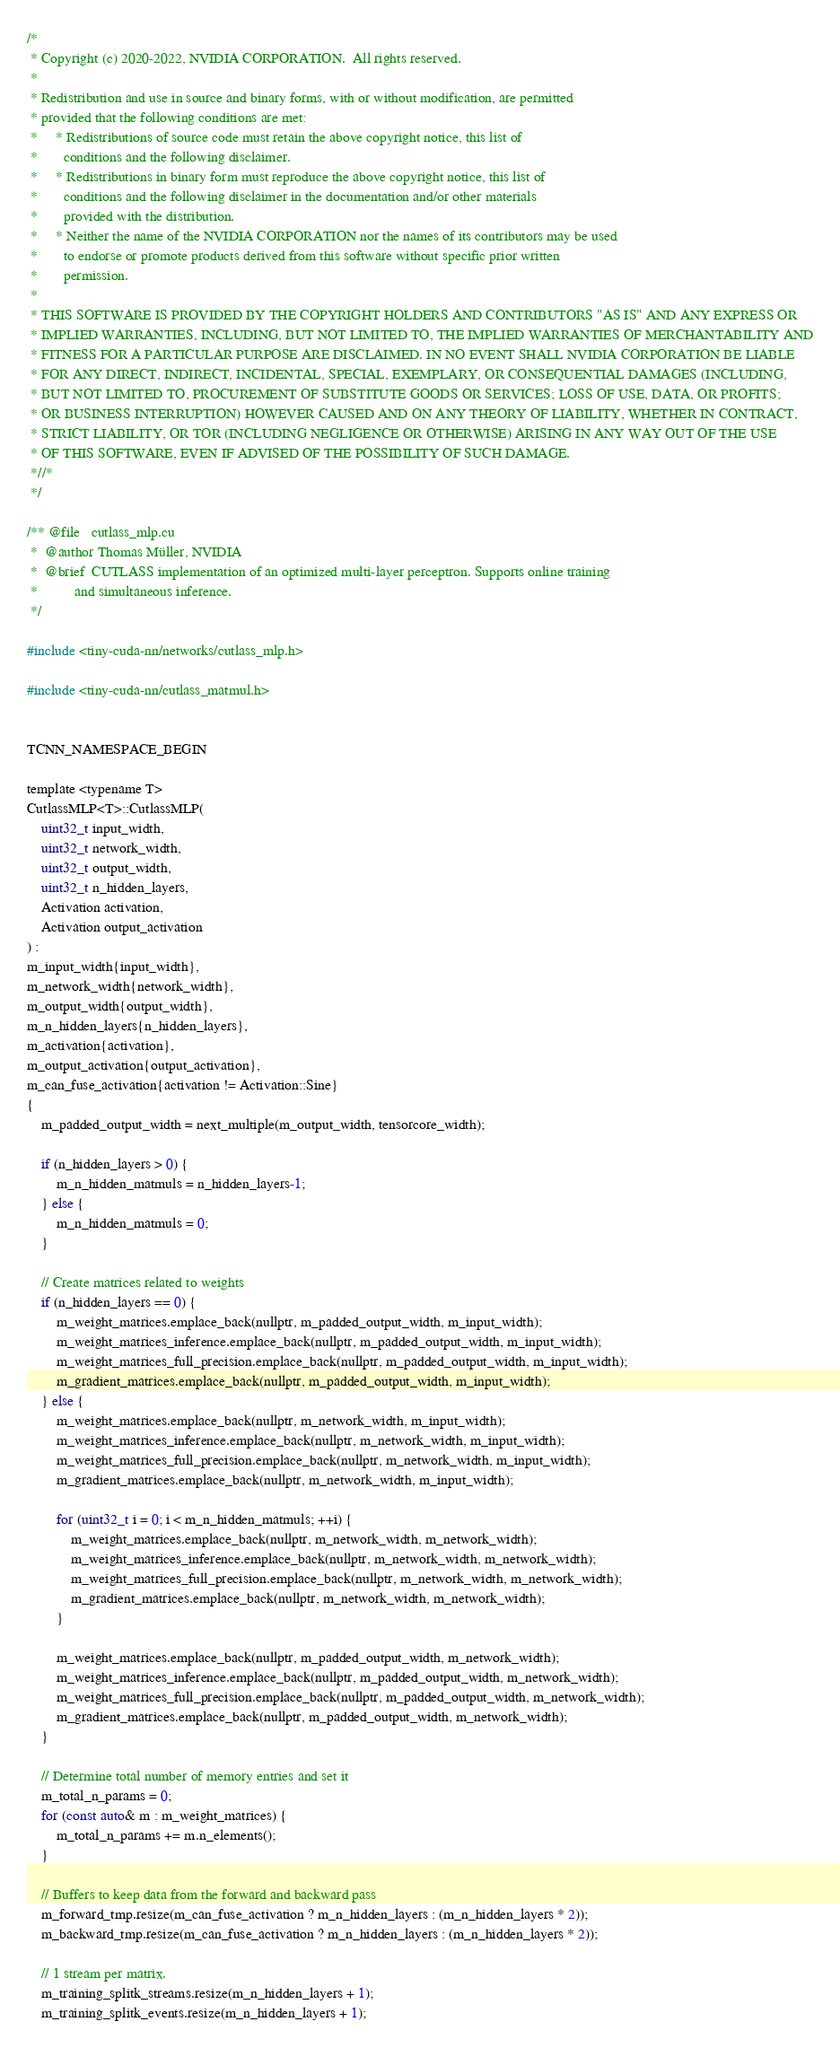Convert code to text. <code><loc_0><loc_0><loc_500><loc_500><_Cuda_>/*
 * Copyright (c) 2020-2022, NVIDIA CORPORATION.  All rights reserved.
 * 
 * Redistribution and use in source and binary forms, with or without modification, are permitted
 * provided that the following conditions are met:
 *     * Redistributions of source code must retain the above copyright notice, this list of
 *       conditions and the following disclaimer.
 *     * Redistributions in binary form must reproduce the above copyright notice, this list of
 *       conditions and the following disclaimer in the documentation and/or other materials
 *       provided with the distribution.
 *     * Neither the name of the NVIDIA CORPORATION nor the names of its contributors may be used
 *       to endorse or promote products derived from this software without specific prior written
 *       permission.
 * 
 * THIS SOFTWARE IS PROVIDED BY THE COPYRIGHT HOLDERS AND CONTRIBUTORS "AS IS" AND ANY EXPRESS OR
 * IMPLIED WARRANTIES, INCLUDING, BUT NOT LIMITED TO, THE IMPLIED WARRANTIES OF MERCHANTABILITY AND
 * FITNESS FOR A PARTICULAR PURPOSE ARE DISCLAIMED. IN NO EVENT SHALL NVIDIA CORPORATION BE LIABLE
 * FOR ANY DIRECT, INDIRECT, INCIDENTAL, SPECIAL, EXEMPLARY, OR CONSEQUENTIAL DAMAGES (INCLUDING,
 * BUT NOT LIMITED TO, PROCUREMENT OF SUBSTITUTE GOODS OR SERVICES; LOSS OF USE, DATA, OR PROFITS;
 * OR BUSINESS INTERRUPTION) HOWEVER CAUSED AND ON ANY THEORY OF LIABILITY, WHETHER IN CONTRACT,
 * STRICT LIABILITY, OR TOR (INCLUDING NEGLIGENCE OR OTHERWISE) ARISING IN ANY WAY OUT OF THE USE
 * OF THIS SOFTWARE, EVEN IF ADVISED OF THE POSSIBILITY OF SUCH DAMAGE.
 *//*
 */

/** @file   cutlass_mlp.cu
 *  @author Thomas Müller, NVIDIA
 *  @brief  CUTLASS implementation of an optimized multi-layer perceptron. Supports online training
 *          and simultaneous inference.
 */

#include <tiny-cuda-nn/networks/cutlass_mlp.h>

#include <tiny-cuda-nn/cutlass_matmul.h>


TCNN_NAMESPACE_BEGIN

template <typename T>
CutlassMLP<T>::CutlassMLP(
	uint32_t input_width,
	uint32_t network_width,
	uint32_t output_width,
	uint32_t n_hidden_layers,
	Activation activation,
	Activation output_activation
) :
m_input_width{input_width},
m_network_width{network_width},
m_output_width{output_width},
m_n_hidden_layers{n_hidden_layers},
m_activation{activation},
m_output_activation{output_activation},
m_can_fuse_activation{activation != Activation::Sine}
{
	m_padded_output_width = next_multiple(m_output_width, tensorcore_width);

	if (n_hidden_layers > 0) {
		m_n_hidden_matmuls = n_hidden_layers-1;
	} else {
		m_n_hidden_matmuls = 0;
	}

	// Create matrices related to weights
	if (n_hidden_layers == 0) {
		m_weight_matrices.emplace_back(nullptr, m_padded_output_width, m_input_width);
		m_weight_matrices_inference.emplace_back(nullptr, m_padded_output_width, m_input_width);
		m_weight_matrices_full_precision.emplace_back(nullptr, m_padded_output_width, m_input_width);
		m_gradient_matrices.emplace_back(nullptr, m_padded_output_width, m_input_width);
	} else {
		m_weight_matrices.emplace_back(nullptr, m_network_width, m_input_width);
		m_weight_matrices_inference.emplace_back(nullptr, m_network_width, m_input_width);
		m_weight_matrices_full_precision.emplace_back(nullptr, m_network_width, m_input_width);
		m_gradient_matrices.emplace_back(nullptr, m_network_width, m_input_width);

		for (uint32_t i = 0; i < m_n_hidden_matmuls; ++i) {
			m_weight_matrices.emplace_back(nullptr, m_network_width, m_network_width);
			m_weight_matrices_inference.emplace_back(nullptr, m_network_width, m_network_width);
			m_weight_matrices_full_precision.emplace_back(nullptr, m_network_width, m_network_width);
			m_gradient_matrices.emplace_back(nullptr, m_network_width, m_network_width);
		}

		m_weight_matrices.emplace_back(nullptr, m_padded_output_width, m_network_width);
		m_weight_matrices_inference.emplace_back(nullptr, m_padded_output_width, m_network_width);
		m_weight_matrices_full_precision.emplace_back(nullptr, m_padded_output_width, m_network_width);
		m_gradient_matrices.emplace_back(nullptr, m_padded_output_width, m_network_width);
	}

	// Determine total number of memory entries and set it
	m_total_n_params = 0;
	for (const auto& m : m_weight_matrices) {
		m_total_n_params += m.n_elements();
	}

	// Buffers to keep data from the forward and backward pass
	m_forward_tmp.resize(m_can_fuse_activation ? m_n_hidden_layers : (m_n_hidden_layers * 2));
	m_backward_tmp.resize(m_can_fuse_activation ? m_n_hidden_layers : (m_n_hidden_layers * 2));

	// 1 stream per matrix.
	m_training_splitk_streams.resize(m_n_hidden_layers + 1);
	m_training_splitk_events.resize(m_n_hidden_layers + 1);
</code> 